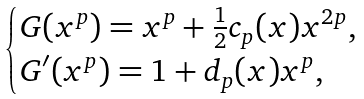<formula> <loc_0><loc_0><loc_500><loc_500>\begin{cases} G ( x ^ { p } ) = x ^ { p } + \frac { 1 } { 2 } c _ { p } ( x ) x ^ { 2 p } , \\ G ^ { \prime } ( x ^ { p } ) = 1 + d _ { p } ( x ) x ^ { p } , \end{cases}</formula> 